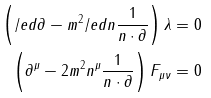<formula> <loc_0><loc_0><loc_500><loc_500>\left ( \slash e d { \partial } - m ^ { 2 } \slash e d { n } \frac { 1 } { n \cdot \partial } \right ) \lambda = 0 \\ \left ( \partial ^ { \mu } - 2 m ^ { 2 } n ^ { \mu } \frac { 1 } { n \cdot \partial } \right ) F _ { \mu \nu } = 0</formula> 